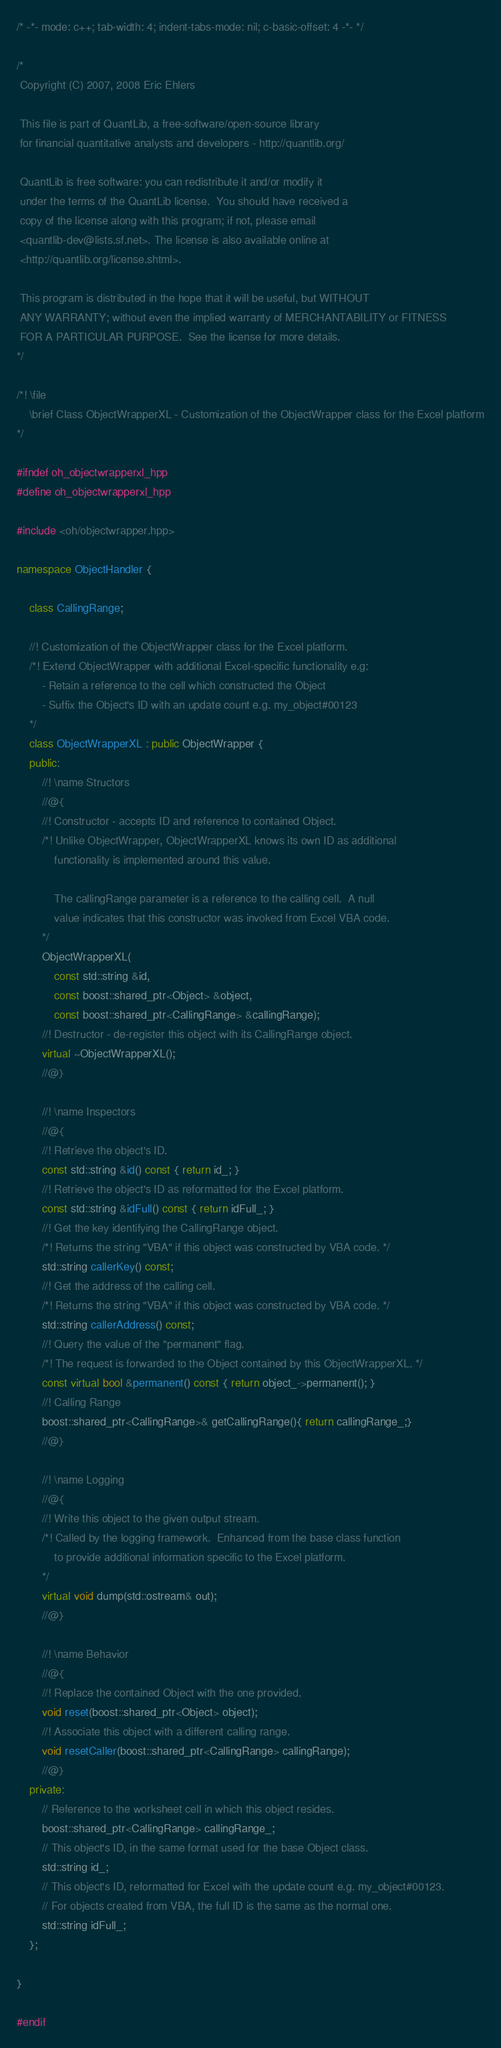<code> <loc_0><loc_0><loc_500><loc_500><_C++_>/* -*- mode: c++; tab-width: 4; indent-tabs-mode: nil; c-basic-offset: 4 -*- */

/*
 Copyright (C) 2007, 2008 Eric Ehlers

 This file is part of QuantLib, a free-software/open-source library
 for financial quantitative analysts and developers - http://quantlib.org/

 QuantLib is free software: you can redistribute it and/or modify it
 under the terms of the QuantLib license.  You should have received a
 copy of the license along with this program; if not, please email
 <quantlib-dev@lists.sf.net>. The license is also available online at
 <http://quantlib.org/license.shtml>.

 This program is distributed in the hope that it will be useful, but WITHOUT
 ANY WARRANTY; without even the implied warranty of MERCHANTABILITY or FITNESS
 FOR A PARTICULAR PURPOSE.  See the license for more details.
*/

/*! \file
    \brief Class ObjectWrapperXL - Customization of the ObjectWrapper class for the Excel platform
*/

#ifndef oh_objectwrapperxl_hpp
#define oh_objectwrapperxl_hpp

#include <oh/objectwrapper.hpp>

namespace ObjectHandler {

    class CallingRange;

    //! Customization of the ObjectWrapper class for the Excel platform.
    /*! Extend ObjectWrapper with additional Excel-specific functionality e.g:
        - Retain a reference to the cell which constructed the Object
        - Suffix the Object's ID with an update count e.g. my_object#00123
    */
    class ObjectWrapperXL : public ObjectWrapper {
    public:
        //! \name Structors
        //@{
        //! Constructor - accepts ID and reference to contained Object.
        /*! Unlike ObjectWrapper, ObjectWrapperXL knows its own ID as additional
            functionality is implemented around this value.

            The callingRange parameter is a reference to the calling cell.  A null
            value indicates that this constructor was invoked from Excel VBA code.
        */
        ObjectWrapperXL(
            const std::string &id,
            const boost::shared_ptr<Object> &object,
            const boost::shared_ptr<CallingRange> &callingRange);
        //! Destructor - de-register this object with its CallingRange object.
        virtual ~ObjectWrapperXL();
        //@}

        //! \name Inspectors
        //@{
        //! Retrieve the object's ID.
        const std::string &id() const { return id_; }
        //! Retrieve the object's ID as reformatted for the Excel platform.
        const std::string &idFull() const { return idFull_; }
        //! Get the key identifying the CallingRange object.
        /*! Returns the string "VBA" if this object was constructed by VBA code. */
        std::string callerKey() const;
        //! Get the address of the calling cell.
        /*! Returns the string "VBA" if this object was constructed by VBA code. */
        std::string callerAddress() const;
        //! Query the value of the "permanent" flag.
        /*! The request is forwarded to the Object contained by this ObjectWrapperXL. */
        const virtual bool &permanent() const { return object_->permanent(); }
        //! Calling Range
        boost::shared_ptr<CallingRange>& getCallingRange(){ return callingRange_;}
        //@}

        //! \name Logging
        //@{
        //! Write this object to the given output stream.
        /*! Called by the logging framework.  Enhanced from the base class function
            to provide additional information specific to the Excel platform.
        */
        virtual void dump(std::ostream& out);
        //@}

        //! \name Behavior
        //@{
        //! Replace the contained Object with the one provided.
        void reset(boost::shared_ptr<Object> object);
        //! Associate this object with a different calling range.
        void resetCaller(boost::shared_ptr<CallingRange> callingRange);
        //@}
    private:
        // Reference to the worksheet cell in which this object resides.
        boost::shared_ptr<CallingRange> callingRange_;
        // This object's ID, in the same format used for the base Object class.
        std::string id_;
        // This object's ID, reformatted for Excel with the update count e.g. my_object#00123.
        // For objects created from VBA, the full ID is the same as the normal one.
        std::string idFull_;
    };

}

#endif

</code> 